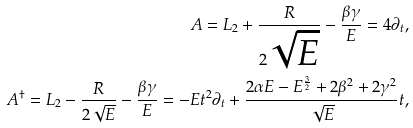Convert formula to latex. <formula><loc_0><loc_0><loc_500><loc_500>A = L _ { 2 } + \frac { R } { 2 \sqrt { E } } - \frac { \beta \gamma } { E } = 4 \partial _ { t } , \\ A ^ { \dagger } = L _ { 2 } - \frac { R } { 2 \sqrt { E } } - \frac { \beta \gamma } { E } = - E t ^ { 2 } \partial _ { t } + \frac { 2 \alpha E - E ^ { \frac { 3 } { 2 } } + 2 \beta ^ { 2 } + 2 \gamma ^ { 2 } } { \sqrt { E } } t ,</formula> 